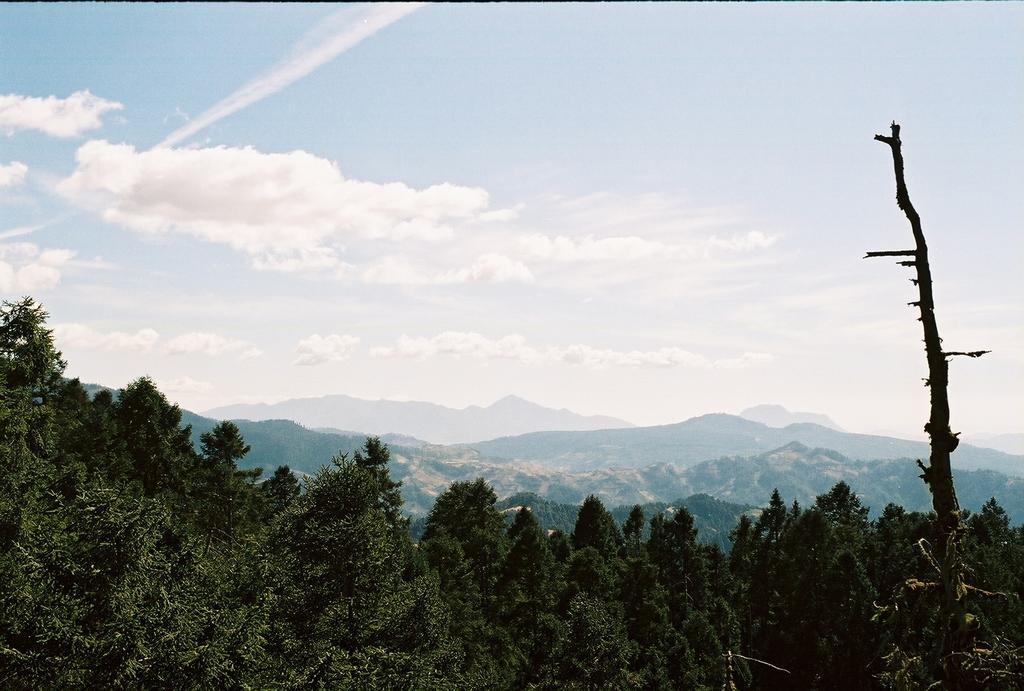Can you describe this image briefly? In this image, I can see the trees and hills. In the background, there is the sky. 